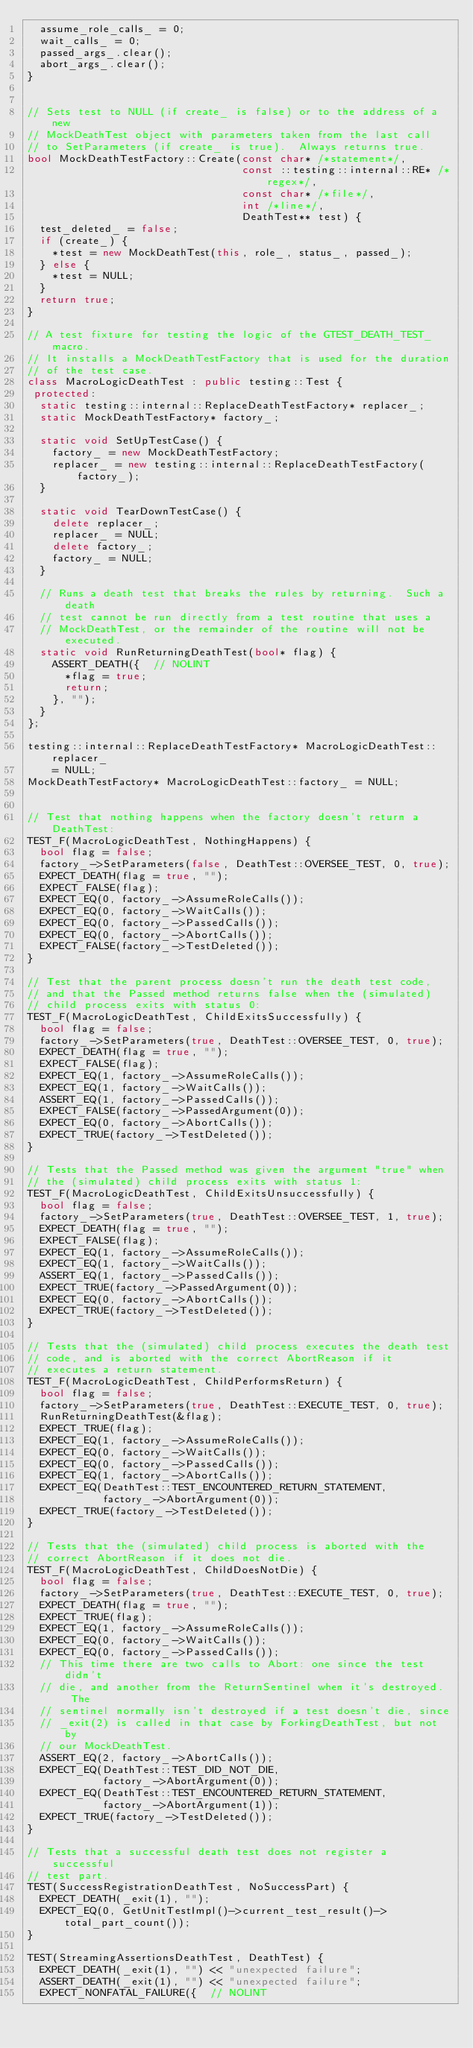Convert code to text. <code><loc_0><loc_0><loc_500><loc_500><_C++_>  assume_role_calls_ = 0;
  wait_calls_ = 0;
  passed_args_.clear();
  abort_args_.clear();
}


// Sets test to NULL (if create_ is false) or to the address of a new
// MockDeathTest object with parameters taken from the last call
// to SetParameters (if create_ is true).  Always returns true.
bool MockDeathTestFactory::Create(const char* /*statement*/,
                                  const ::testing::internal::RE* /*regex*/,
                                  const char* /*file*/,
                                  int /*line*/,
                                  DeathTest** test) {
  test_deleted_ = false;
  if (create_) {
    *test = new MockDeathTest(this, role_, status_, passed_);
  } else {
    *test = NULL;
  }
  return true;
}

// A test fixture for testing the logic of the GTEST_DEATH_TEST_ macro.
// It installs a MockDeathTestFactory that is used for the duration
// of the test case.
class MacroLogicDeathTest : public testing::Test {
 protected:
  static testing::internal::ReplaceDeathTestFactory* replacer_;
  static MockDeathTestFactory* factory_;

  static void SetUpTestCase() {
    factory_ = new MockDeathTestFactory;
    replacer_ = new testing::internal::ReplaceDeathTestFactory(factory_);
  }

  static void TearDownTestCase() {
    delete replacer_;
    replacer_ = NULL;
    delete factory_;
    factory_ = NULL;
  }

  // Runs a death test that breaks the rules by returning.  Such a death
  // test cannot be run directly from a test routine that uses a
  // MockDeathTest, or the remainder of the routine will not be executed.
  static void RunReturningDeathTest(bool* flag) {
    ASSERT_DEATH({  // NOLINT
      *flag = true;
      return;
    }, "");
  }
};

testing::internal::ReplaceDeathTestFactory* MacroLogicDeathTest::replacer_
    = NULL;
MockDeathTestFactory* MacroLogicDeathTest::factory_ = NULL;


// Test that nothing happens when the factory doesn't return a DeathTest:
TEST_F(MacroLogicDeathTest, NothingHappens) {
  bool flag = false;
  factory_->SetParameters(false, DeathTest::OVERSEE_TEST, 0, true);
  EXPECT_DEATH(flag = true, "");
  EXPECT_FALSE(flag);
  EXPECT_EQ(0, factory_->AssumeRoleCalls());
  EXPECT_EQ(0, factory_->WaitCalls());
  EXPECT_EQ(0, factory_->PassedCalls());
  EXPECT_EQ(0, factory_->AbortCalls());
  EXPECT_FALSE(factory_->TestDeleted());
}

// Test that the parent process doesn't run the death test code,
// and that the Passed method returns false when the (simulated)
// child process exits with status 0:
TEST_F(MacroLogicDeathTest, ChildExitsSuccessfully) {
  bool flag = false;
  factory_->SetParameters(true, DeathTest::OVERSEE_TEST, 0, true);
  EXPECT_DEATH(flag = true, "");
  EXPECT_FALSE(flag);
  EXPECT_EQ(1, factory_->AssumeRoleCalls());
  EXPECT_EQ(1, factory_->WaitCalls());
  ASSERT_EQ(1, factory_->PassedCalls());
  EXPECT_FALSE(factory_->PassedArgument(0));
  EXPECT_EQ(0, factory_->AbortCalls());
  EXPECT_TRUE(factory_->TestDeleted());
}

// Tests that the Passed method was given the argument "true" when
// the (simulated) child process exits with status 1:
TEST_F(MacroLogicDeathTest, ChildExitsUnsuccessfully) {
  bool flag = false;
  factory_->SetParameters(true, DeathTest::OVERSEE_TEST, 1, true);
  EXPECT_DEATH(flag = true, "");
  EXPECT_FALSE(flag);
  EXPECT_EQ(1, factory_->AssumeRoleCalls());
  EXPECT_EQ(1, factory_->WaitCalls());
  ASSERT_EQ(1, factory_->PassedCalls());
  EXPECT_TRUE(factory_->PassedArgument(0));
  EXPECT_EQ(0, factory_->AbortCalls());
  EXPECT_TRUE(factory_->TestDeleted());
}

// Tests that the (simulated) child process executes the death test
// code, and is aborted with the correct AbortReason if it
// executes a return statement.
TEST_F(MacroLogicDeathTest, ChildPerformsReturn) {
  bool flag = false;
  factory_->SetParameters(true, DeathTest::EXECUTE_TEST, 0, true);
  RunReturningDeathTest(&flag);
  EXPECT_TRUE(flag);
  EXPECT_EQ(1, factory_->AssumeRoleCalls());
  EXPECT_EQ(0, factory_->WaitCalls());
  EXPECT_EQ(0, factory_->PassedCalls());
  EXPECT_EQ(1, factory_->AbortCalls());
  EXPECT_EQ(DeathTest::TEST_ENCOUNTERED_RETURN_STATEMENT,
            factory_->AbortArgument(0));
  EXPECT_TRUE(factory_->TestDeleted());
}

// Tests that the (simulated) child process is aborted with the
// correct AbortReason if it does not die.
TEST_F(MacroLogicDeathTest, ChildDoesNotDie) {
  bool flag = false;
  factory_->SetParameters(true, DeathTest::EXECUTE_TEST, 0, true);
  EXPECT_DEATH(flag = true, "");
  EXPECT_TRUE(flag);
  EXPECT_EQ(1, factory_->AssumeRoleCalls());
  EXPECT_EQ(0, factory_->WaitCalls());
  EXPECT_EQ(0, factory_->PassedCalls());
  // This time there are two calls to Abort: one since the test didn't
  // die, and another from the ReturnSentinel when it's destroyed.  The
  // sentinel normally isn't destroyed if a test doesn't die, since
  // _exit(2) is called in that case by ForkingDeathTest, but not by
  // our MockDeathTest.
  ASSERT_EQ(2, factory_->AbortCalls());
  EXPECT_EQ(DeathTest::TEST_DID_NOT_DIE,
            factory_->AbortArgument(0));
  EXPECT_EQ(DeathTest::TEST_ENCOUNTERED_RETURN_STATEMENT,
            factory_->AbortArgument(1));
  EXPECT_TRUE(factory_->TestDeleted());
}

// Tests that a successful death test does not register a successful
// test part.
TEST(SuccessRegistrationDeathTest, NoSuccessPart) {
  EXPECT_DEATH(_exit(1), "");
  EXPECT_EQ(0, GetUnitTestImpl()->current_test_result()->total_part_count());
}

TEST(StreamingAssertionsDeathTest, DeathTest) {
  EXPECT_DEATH(_exit(1), "") << "unexpected failure";
  ASSERT_DEATH(_exit(1), "") << "unexpected failure";
  EXPECT_NONFATAL_FAILURE({  // NOLINT</code> 